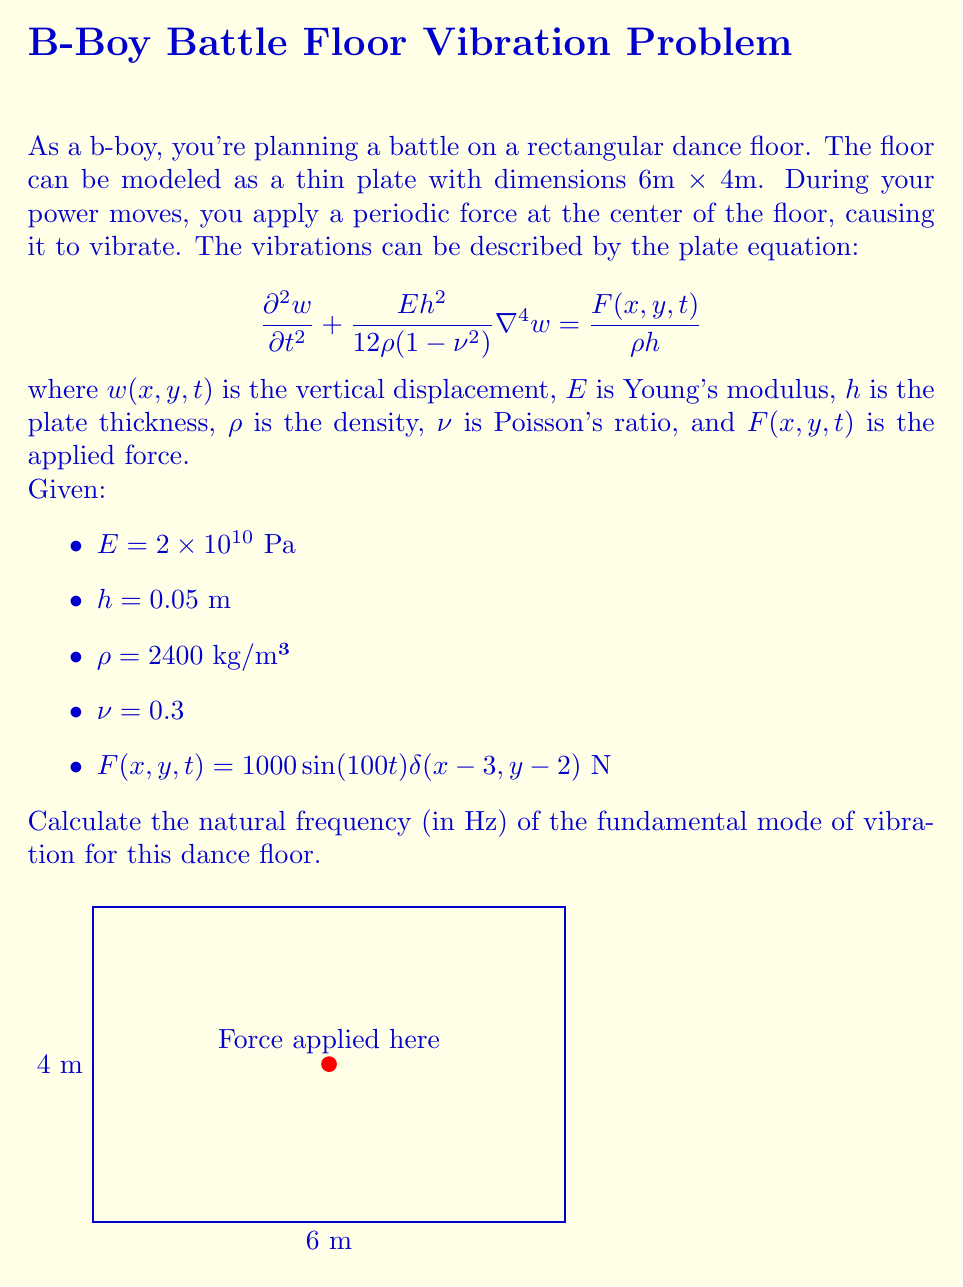Solve this math problem. To solve this problem, we need to follow these steps:

1) The natural frequency of the fundamental mode for a rectangular plate with simply supported edges is given by:

   $$f = \frac{1}{2\pi}\sqrt{\frac{D}{\rho h}}\sqrt{\left(\frac{\pi}{a}\right)^2 + \left(\frac{\pi}{b}\right)^2}$$

   where $D = \frac{Eh^3}{12(1-\nu^2)}$ is the flexural rigidity, $a$ and $b$ are the plate dimensions.

2) Calculate the flexural rigidity $D$:
   
   $$D = \frac{(2 \times 10^{10})(0.05)^3}{12(1-0.3^2)} = 2314.81 \text{ N⋅m}$$

3) Substitute the values into the frequency equation:

   $$f = \frac{1}{2\pi}\sqrt{\frac{2314.81}{2400 \times 0.05}}\sqrt{\left(\frac{\pi}{6}\right)^2 + \left(\frac{\pi}{4}\right)^2}$$

4) Simplify and calculate:

   $$f = \frac{1}{2\pi}\sqrt{19290.08}\sqrt{0.2737 + 0.6158}$$
   $$f = \frac{1}{2\pi}\sqrt{19290.08 \times 0.8895}$$
   $$f = \frac{1}{2\pi}\sqrt{17158.53}$$
   $$f = 20.82 \text{ Hz}$$

Thus, the natural frequency of the fundamental mode is approximately 20.82 Hz.
Answer: 20.82 Hz 